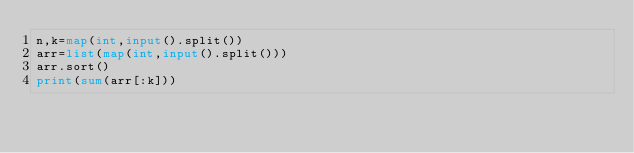Convert code to text. <code><loc_0><loc_0><loc_500><loc_500><_Python_>n,k=map(int,input().split())
arr=list(map(int,input().split()))
arr.sort()
print(sum(arr[:k]))
</code> 